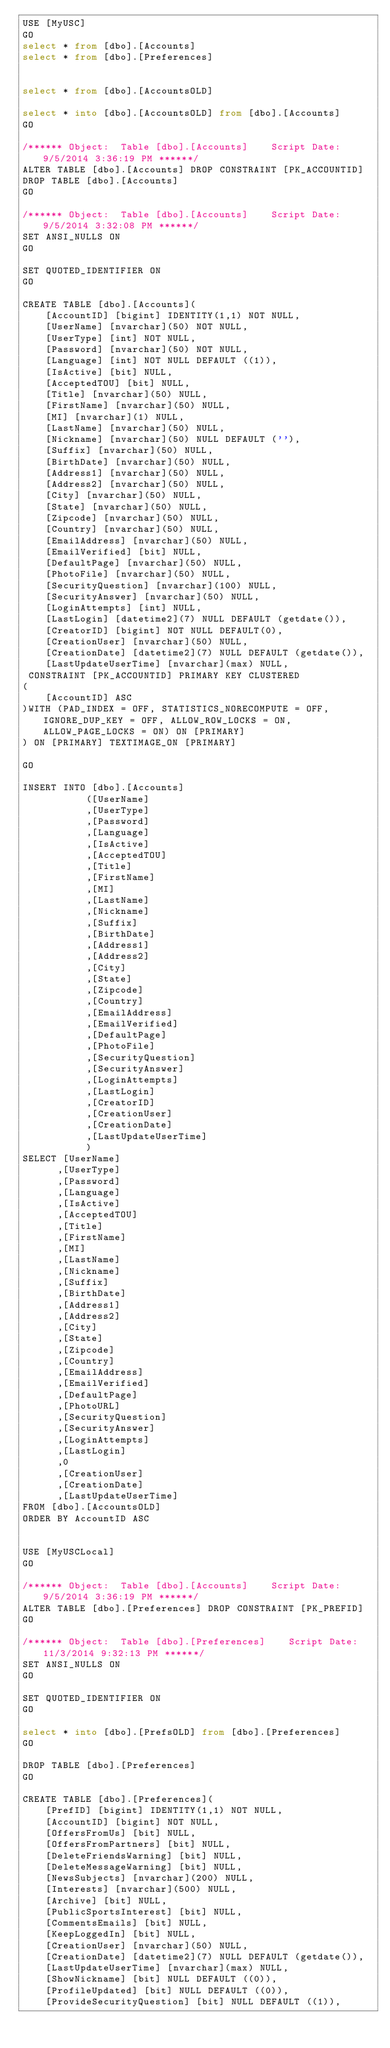Convert code to text. <code><loc_0><loc_0><loc_500><loc_500><_SQL_>USE [MyUSC]
GO
select * from [dbo].[Accounts]
select * from [dbo].[Preferences]


select * from [dbo].[AccountsOLD]

select * into [dbo].[AccountsOLD] from [dbo].[Accounts]
GO

/****** Object:  Table [dbo].[Accounts]    Script Date: 9/5/2014 3:36:19 PM ******/
ALTER TABLE [dbo].[Accounts] DROP CONSTRAINT [PK_ACCOUNTID]
DROP TABLE [dbo].[Accounts]
GO

/****** Object:  Table [dbo].[Accounts]    Script Date: 9/5/2014 3:32:08 PM ******/
SET ANSI_NULLS ON
GO

SET QUOTED_IDENTIFIER ON
GO

CREATE TABLE [dbo].[Accounts](
	[AccountID] [bigint] IDENTITY(1,1) NOT NULL,
	[UserName] [nvarchar](50) NOT NULL,
	[UserType] [int] NOT NULL,
	[Password] [nvarchar](50) NOT NULL,
	[Language] [int] NOT NULL DEFAULT ((1)),
	[IsActive] [bit] NULL,
	[AcceptedTOU] [bit] NULL,
	[Title] [nvarchar](50) NULL,
	[FirstName] [nvarchar](50) NULL,
	[MI] [nvarchar](1) NULL,
	[LastName] [nvarchar](50) NULL,
	[Nickname] [nvarchar](50) NULL DEFAULT (''),
	[Suffix] [nvarchar](50) NULL,
	[BirthDate] [nvarchar](50) NULL,
	[Address1] [nvarchar](50) NULL,
	[Address2] [nvarchar](50) NULL,
	[City] [nvarchar](50) NULL,
	[State] [nvarchar](50) NULL,
	[Zipcode] [nvarchar](50) NULL,
	[Country] [nvarchar](50) NULL,
	[EmailAddress] [nvarchar](50) NULL,
	[EmailVerified] [bit] NULL,
	[DefaultPage] [nvarchar](50) NULL,
	[PhotoFile] [nvarchar](50) NULL,
	[SecurityQuestion] [nvarchar](100) NULL,
	[SecurityAnswer] [nvarchar](50) NULL,
	[LoginAttempts] [int] NULL,
	[LastLogin] [datetime2](7) NULL DEFAULT (getdate()),
	[CreatorID] [bigint] NOT NULL DEFAULT(0),
	[CreationUser] [nvarchar](50) NULL,
	[CreationDate] [datetime2](7) NULL DEFAULT (getdate()),
	[LastUpdateUserTime] [nvarchar](max) NULL,
 CONSTRAINT [PK_ACCOUNTID] PRIMARY KEY CLUSTERED 
(
	[AccountID] ASC
)WITH (PAD_INDEX = OFF, STATISTICS_NORECOMPUTE = OFF, IGNORE_DUP_KEY = OFF, ALLOW_ROW_LOCKS = ON, ALLOW_PAGE_LOCKS = ON) ON [PRIMARY]
) ON [PRIMARY] TEXTIMAGE_ON [PRIMARY]

GO

INSERT INTO [dbo].[Accounts]
           ([UserName]
           ,[UserType]
           ,[Password]
           ,[Language]
           ,[IsActive]
           ,[AcceptedTOU]
           ,[Title]
           ,[FirstName]
           ,[MI]
           ,[LastName]
		   ,[Nickname]
           ,[Suffix]
           ,[BirthDate]
           ,[Address1]
           ,[Address2]
           ,[City]
           ,[State]
           ,[Zipcode]
           ,[Country]
           ,[EmailAddress]
           ,[EmailVerified]
           ,[DefaultPage]
           ,[PhotoFile]
           ,[SecurityQuestion]
           ,[SecurityAnswer]
           ,[LoginAttempts]
		   ,[LastLogin]
		   ,[CreatorID]
           ,[CreationUser]
           ,[CreationDate]
           ,[LastUpdateUserTime]
           )
SELECT [UserName]
      ,[UserType]
      ,[Password]
      ,[Language]
      ,[IsActive]
      ,[AcceptedTOU]
      ,[Title]
      ,[FirstName]
      ,[MI]
      ,[LastName]
      ,[Nickname]
	  ,[Suffix]
      ,[BirthDate]
      ,[Address1]
      ,[Address2]
      ,[City]
      ,[State]
      ,[Zipcode]
      ,[Country]
      ,[EmailAddress]
      ,[EmailVerified]
      ,[DefaultPage]
      ,[PhotoURL]
      ,[SecurityQuestion]
      ,[SecurityAnswer]
      ,[LoginAttempts]
      ,[LastLogin]
      ,0
      ,[CreationUser]
      ,[CreationDate]
      ,[LastUpdateUserTime]
FROM [dbo].[AccountsOLD]
ORDER BY AccountID ASC


USE [MyUSCLocal]
GO

/****** Object:  Table [dbo].[Accounts]    Script Date: 9/5/2014 3:36:19 PM ******/
ALTER TABLE [dbo].[Preferences] DROP CONSTRAINT [PK_PREFID]
GO

/****** Object:  Table [dbo].[Preferences]    Script Date: 11/3/2014 9:32:13 PM ******/
SET ANSI_NULLS ON
GO

SET QUOTED_IDENTIFIER ON
GO

select * into [dbo].[PrefsOLD] from [dbo].[Preferences]
GO

DROP TABLE [dbo].[Preferences]
GO

CREATE TABLE [dbo].[Preferences](
	[PrefID] [bigint] IDENTITY(1,1) NOT NULL,
	[AccountID] [bigint] NOT NULL,
	[OffersFromUs] [bit] NULL,
	[OffersFromPartners] [bit] NULL,
	[DeleteFriendsWarning] [bit] NULL,
	[DeleteMessageWarning] [bit] NULL,
	[NewsSubjects] [nvarchar](200) NULL,
	[Interests] [nvarchar](500) NULL,
	[Archive] [bit] NULL,
	[PublicSportsInterest] [bit] NULL,
	[CommentsEmails] [bit] NULL,
	[KeepLoggedIn] [bit] NULL,
	[CreationUser] [nvarchar](50) NULL,
	[CreationDate] [datetime2](7) NULL DEFAULT (getdate()),
	[LastUpdateUserTime] [nvarchar](max) NULL,
	[ShowNickname] [bit] NULL DEFAULT ((0)),
	[ProfileUpdated] [bit] NULL DEFAULT ((0)),
	[ProvideSecurityQuestion] [bit] NULL DEFAULT ((1)),</code> 